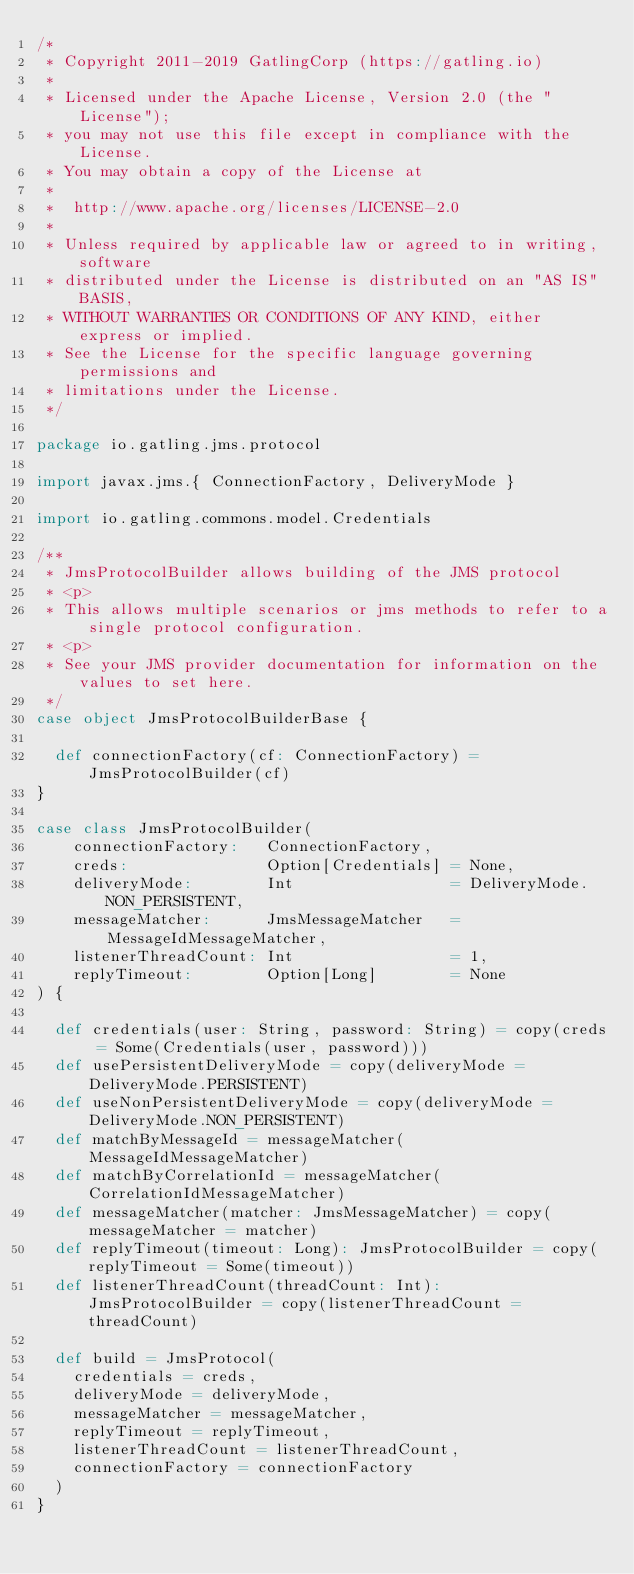<code> <loc_0><loc_0><loc_500><loc_500><_Scala_>/*
 * Copyright 2011-2019 GatlingCorp (https://gatling.io)
 *
 * Licensed under the Apache License, Version 2.0 (the "License");
 * you may not use this file except in compliance with the License.
 * You may obtain a copy of the License at
 *
 *  http://www.apache.org/licenses/LICENSE-2.0
 *
 * Unless required by applicable law or agreed to in writing, software
 * distributed under the License is distributed on an "AS IS" BASIS,
 * WITHOUT WARRANTIES OR CONDITIONS OF ANY KIND, either express or implied.
 * See the License for the specific language governing permissions and
 * limitations under the License.
 */

package io.gatling.jms.protocol

import javax.jms.{ ConnectionFactory, DeliveryMode }

import io.gatling.commons.model.Credentials

/**
 * JmsProtocolBuilder allows building of the JMS protocol
 * <p>
 * This allows multiple scenarios or jms methods to refer to a single protocol configuration.
 * <p>
 * See your JMS provider documentation for information on the values to set here.
 */
case object JmsProtocolBuilderBase {

  def connectionFactory(cf: ConnectionFactory) = JmsProtocolBuilder(cf)
}

case class JmsProtocolBuilder(
    connectionFactory:   ConnectionFactory,
    creds:               Option[Credentials] = None,
    deliveryMode:        Int                 = DeliveryMode.NON_PERSISTENT,
    messageMatcher:      JmsMessageMatcher   = MessageIdMessageMatcher,
    listenerThreadCount: Int                 = 1,
    replyTimeout:        Option[Long]        = None
) {

  def credentials(user: String, password: String) = copy(creds = Some(Credentials(user, password)))
  def usePersistentDeliveryMode = copy(deliveryMode = DeliveryMode.PERSISTENT)
  def useNonPersistentDeliveryMode = copy(deliveryMode = DeliveryMode.NON_PERSISTENT)
  def matchByMessageId = messageMatcher(MessageIdMessageMatcher)
  def matchByCorrelationId = messageMatcher(CorrelationIdMessageMatcher)
  def messageMatcher(matcher: JmsMessageMatcher) = copy(messageMatcher = matcher)
  def replyTimeout(timeout: Long): JmsProtocolBuilder = copy(replyTimeout = Some(timeout))
  def listenerThreadCount(threadCount: Int): JmsProtocolBuilder = copy(listenerThreadCount = threadCount)

  def build = JmsProtocol(
    credentials = creds,
    deliveryMode = deliveryMode,
    messageMatcher = messageMatcher,
    replyTimeout = replyTimeout,
    listenerThreadCount = listenerThreadCount,
    connectionFactory = connectionFactory
  )
}
</code> 